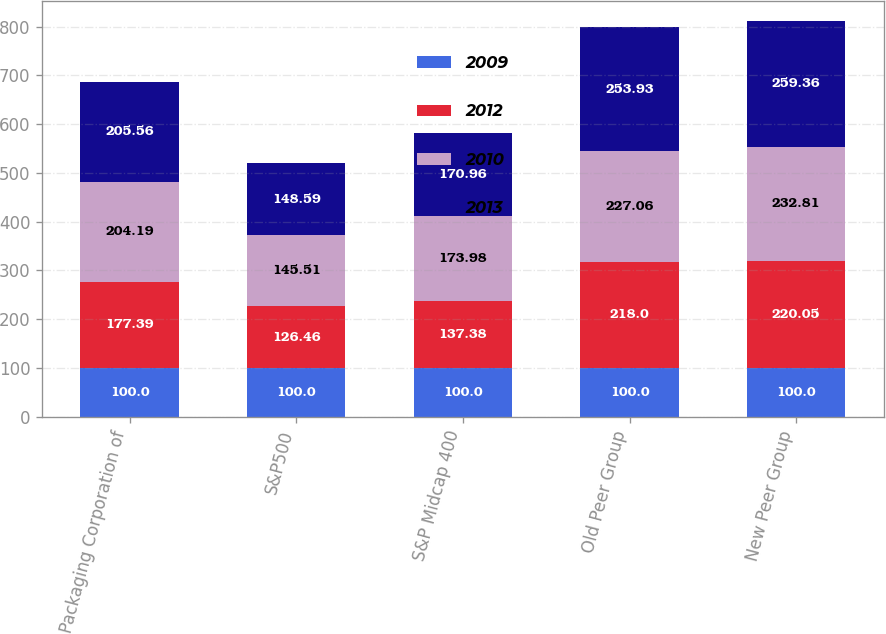<chart> <loc_0><loc_0><loc_500><loc_500><stacked_bar_chart><ecel><fcel>Packaging Corporation of<fcel>S&P500<fcel>S&P Midcap 400<fcel>Old Peer Group<fcel>New Peer Group<nl><fcel>2009<fcel>100<fcel>100<fcel>100<fcel>100<fcel>100<nl><fcel>2012<fcel>177.39<fcel>126.46<fcel>137.38<fcel>218<fcel>220.05<nl><fcel>2010<fcel>204.19<fcel>145.51<fcel>173.98<fcel>227.06<fcel>232.81<nl><fcel>2013<fcel>205.56<fcel>148.59<fcel>170.96<fcel>253.93<fcel>259.36<nl></chart> 